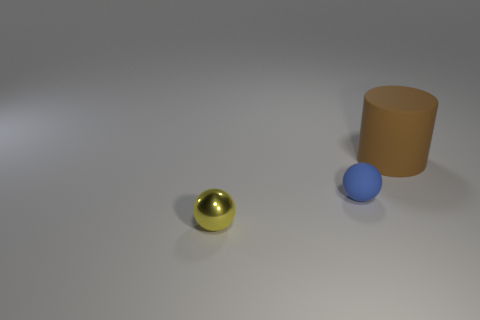How many red objects are cylinders or small rubber things?
Give a very brief answer. 0. There is a sphere that is made of the same material as the brown object; what color is it?
Give a very brief answer. Blue. There is a thing that is on the left side of the large brown rubber cylinder and to the right of the tiny yellow metal object; what color is it?
Provide a succinct answer. Blue. There is a blue object; how many yellow metal spheres are behind it?
Offer a terse response. 0. How many things are big yellow matte things or brown cylinders on the right side of the yellow metal thing?
Keep it short and to the point. 1. There is a tiny object on the right side of the small yellow shiny sphere; is there a matte thing behind it?
Provide a short and direct response. Yes. What color is the matte object in front of the big matte thing?
Keep it short and to the point. Blue. Are there an equal number of metal things in front of the large brown matte thing and green metallic spheres?
Your response must be concise. No. The object that is left of the large brown cylinder and behind the small yellow object has what shape?
Your answer should be very brief. Sphere. What is the color of the other tiny metal thing that is the same shape as the blue thing?
Your response must be concise. Yellow. 